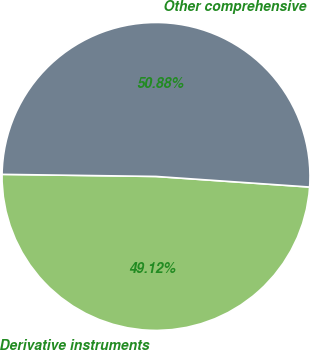Convert chart to OTSL. <chart><loc_0><loc_0><loc_500><loc_500><pie_chart><fcel>Derivative instruments<fcel>Other comprehensive<nl><fcel>49.12%<fcel>50.88%<nl></chart> 